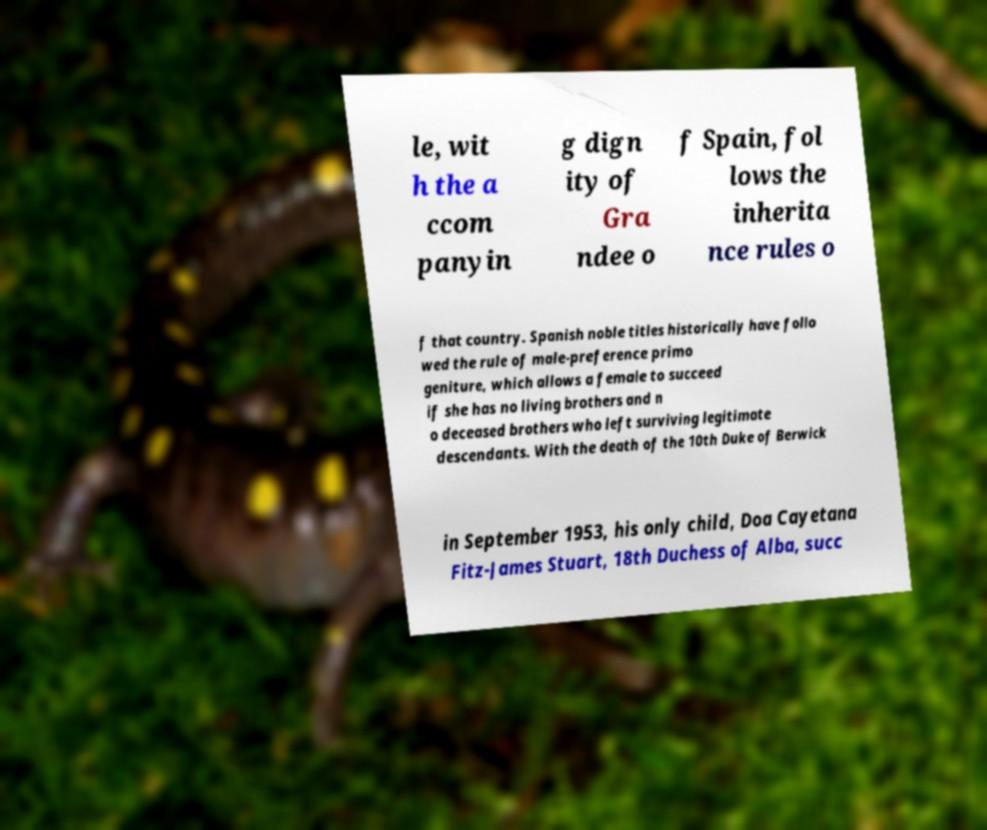Please read and relay the text visible in this image. What does it say? le, wit h the a ccom panyin g dign ity of Gra ndee o f Spain, fol lows the inherita nce rules o f that country. Spanish noble titles historically have follo wed the rule of male-preference primo geniture, which allows a female to succeed if she has no living brothers and n o deceased brothers who left surviving legitimate descendants. With the death of the 10th Duke of Berwick in September 1953, his only child, Doa Cayetana Fitz-James Stuart, 18th Duchess of Alba, succ 